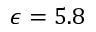<formula> <loc_0><loc_0><loc_500><loc_500>\epsilon = 5 . 8</formula> 